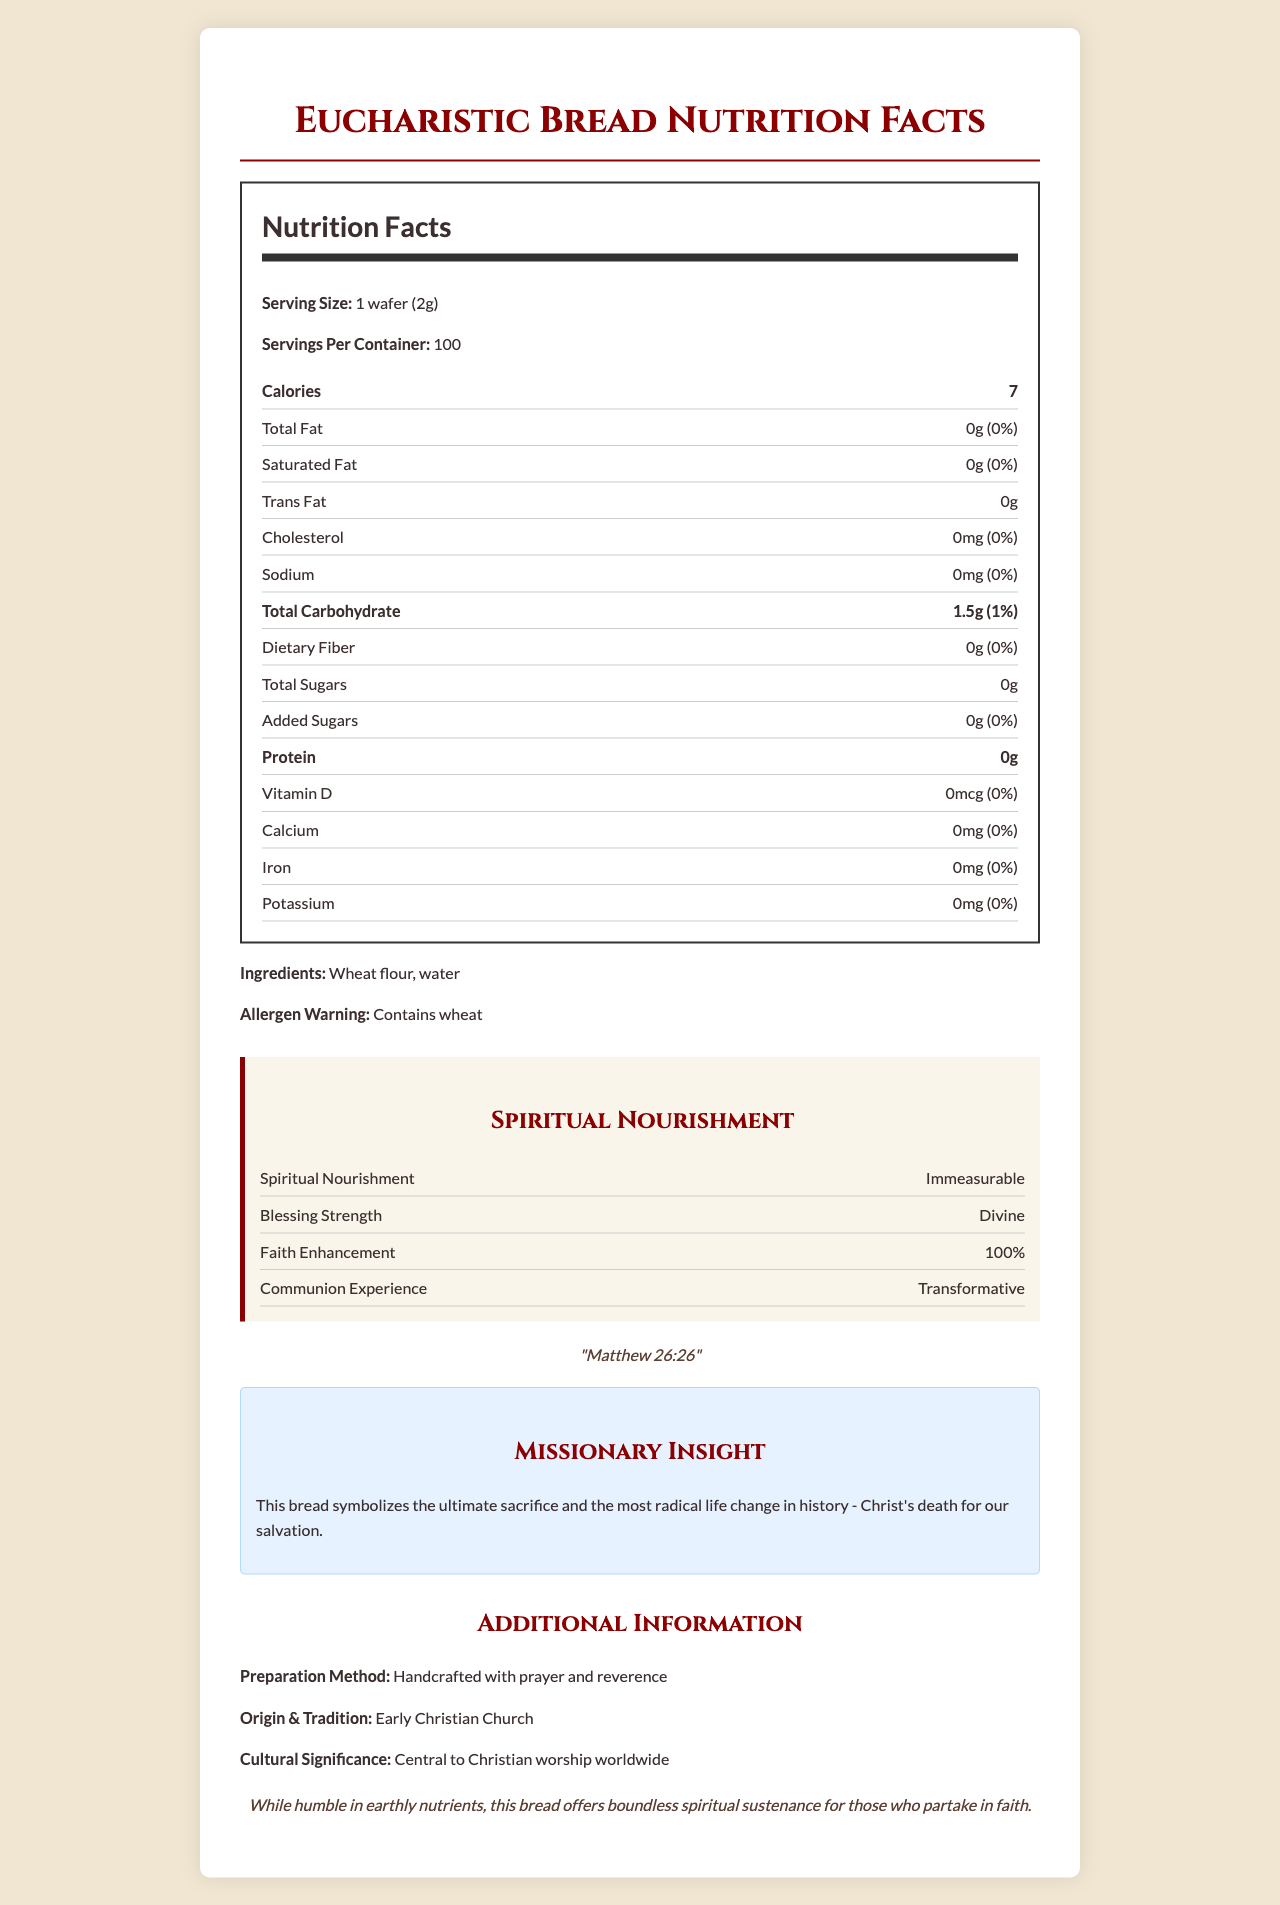What is the serving size of the Eucharistic bread? The serving size is clearly mentioned at the top of the nutrition label as "1 wafer (2g)".
Answer: 1 wafer (2g) How many calories are there per serving of the Eucharistic bread? It is listed under the bold section of the nutrition label indicating "Calories" followed by the number 7.
Answer: 7 calories What is the amount of total fat in one serving of the wafer? In the nutrition label, it specifies "Total Fat: 0g (0%)".
Answer: 0g How many servings are there per container? The number of servings per container is mentioned near the top of the nutrition label as "Servings Per Container: 100".
Answer: 100 What are the main ingredients of the Eucharistic bread? Listed just below the nutrition facts, it mentions "Ingredients: Wheat flour, water".
Answer: Wheat flour, water Which of the following nutrients does the Eucharistic bread contain? A. Vitamin D B. Protein C. Iron D. None of the above The bread contains none of the above as it has 0% of Vitamin D, Protein, and Iron.
Answer: D What is the cultural significance of the Eucharistic bread? A. Central to Buddhist worship B. Central to Jewish worship C. Central to Christian worship D. Central to Islamic worship The document states "Central to Christian worship worldwide".
Answer: C Does the Eucharistic bread contain any dietary fiber? It is mentioned in the nutrition label as "Dietary Fiber: 0g (0%)".
Answer: No Is there any allergen warning associated with the Eucharistic bread? The document includes "Allergen Warning: Contains wheat".
Answer: Yes Summarize the overall nutritional value and spiritual significance of the Eucharistic bread as presented in the document. The document provides detailed nutritional information showing minimal earthly nutrients and highlights its significant spiritual nourishment. It emphasizes the bread's divine and transformative aspects central to Christian worship.
Answer: The Eucharistic bread, with a serving size of 1 wafer (2g), provides minimal nutritional value, containing 7 calories, 0g total fat, 0mg cholesterol, 0mg sodium, and negligible amounts of other nutrients. It is made from wheat flour and water. Despite its humble earthly nutrients, it holds immense spiritual importance, offering immeasurable spiritual nourishment, divine blessing strength, and a transformative communion experience, deeply rooted in Christian tradition and symbolizing Christ's ultimate sacrifice. How is the Eucharistic bread prepared according to the document? The document specifies "Preparation Method: Handcrafted with prayer and reverence".
Answer: Handcrafted with prayer and reverence What is the analogical daily value of Faith Enhancement provided by the Eucharistic bread? The "Faith Enhancement" listed in the spiritual content section is mentioned as "100%".
Answer: 100% What is the sodium content per serving and its daily value percentage? In the nutrition facts section, it states "Sodium: 0mg (0%)".
Answer: 0mg (0%) Who partakes in the Eucharistic bread for spiritual sustenance? This information is not available directly in the document; it mentions faith in general but does not specify a particular group of people who partake.
Answer: Cannot be determined What biblical reference is mentioned in the document? The biblical reference is quoted under the "Spiritual Nourishment" section as "Matthew 26:26".
Answer: Matthew 26:26 Why does the document claim that the Eucharistic bread offers boundless spiritual sustenance? This is explained in the "Missionary Insight" and "spiritual nourishment" sections, emphasizing the bread's profound religious significance and spiritual nourishment.
Answer: The bread offers spiritual sustenance as it symbolizes Christ's ultimate sacrifice for salvation, deeply enhancing faith and providing a divine and transformative communion experience. 